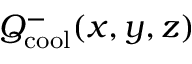<formula> <loc_0><loc_0><loc_500><loc_500>Q _ { c o o l } ^ { - } ( x , y , z )</formula> 